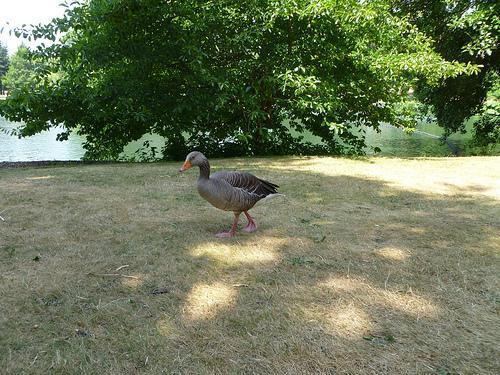How many ducks are shown?
Give a very brief answer. 1. 